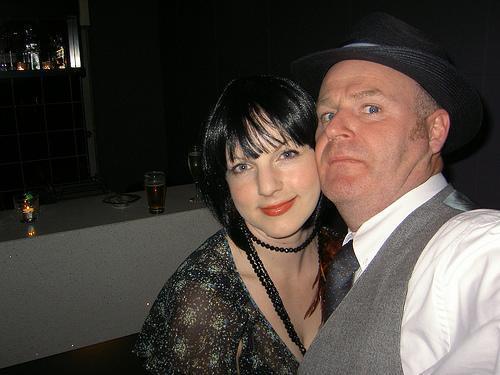How many people are in the photo?
Give a very brief answer. 2. How many glasses are on the countertop?
Give a very brief answer. 3. 